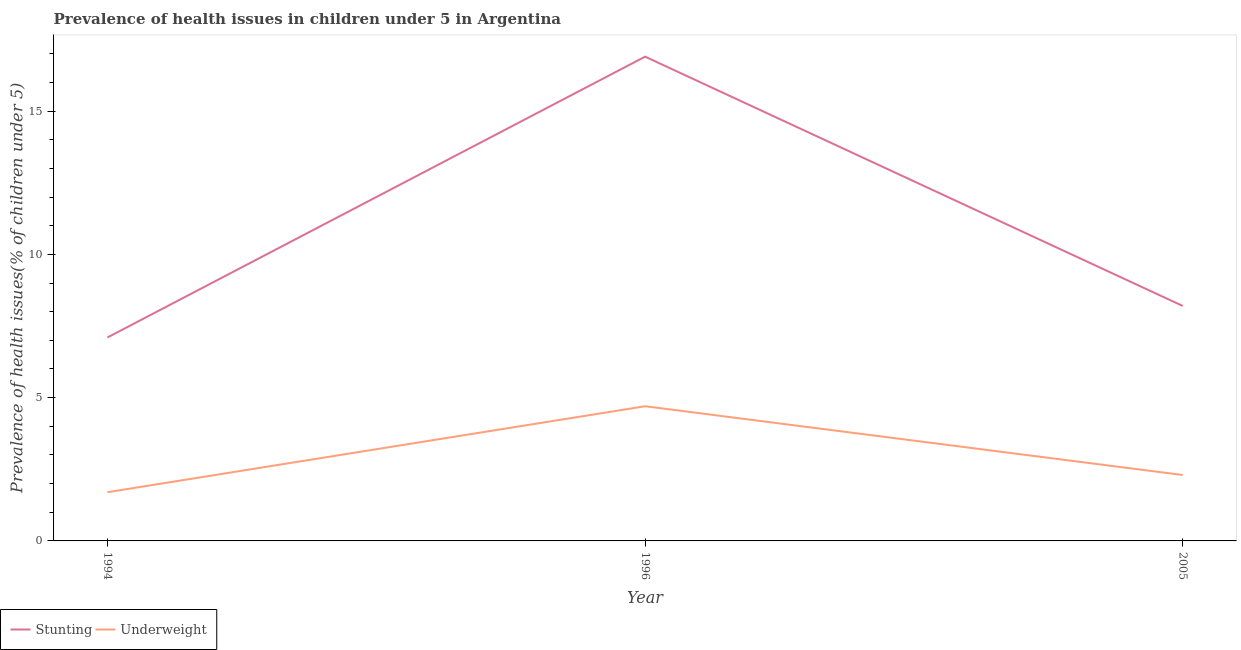What is the percentage of underweight children in 2005?
Provide a short and direct response. 2.3. Across all years, what is the maximum percentage of underweight children?
Your response must be concise. 4.7. Across all years, what is the minimum percentage of underweight children?
Ensure brevity in your answer.  1.7. In which year was the percentage of stunted children maximum?
Make the answer very short. 1996. In which year was the percentage of underweight children minimum?
Offer a terse response. 1994. What is the total percentage of stunted children in the graph?
Your answer should be compact. 32.2. What is the difference between the percentage of stunted children in 1994 and that in 1996?
Provide a short and direct response. -9.8. What is the difference between the percentage of stunted children in 1994 and the percentage of underweight children in 2005?
Provide a succinct answer. 4.8. What is the average percentage of stunted children per year?
Provide a short and direct response. 10.73. In the year 1994, what is the difference between the percentage of stunted children and percentage of underweight children?
Provide a short and direct response. 5.4. In how many years, is the percentage of underweight children greater than 1 %?
Ensure brevity in your answer.  3. What is the ratio of the percentage of stunted children in 1994 to that in 2005?
Give a very brief answer. 0.87. Is the percentage of stunted children in 1994 less than that in 2005?
Give a very brief answer. Yes. What is the difference between the highest and the second highest percentage of underweight children?
Offer a terse response. 2.4. What is the difference between the highest and the lowest percentage of underweight children?
Give a very brief answer. 3. Is the sum of the percentage of underweight children in 1996 and 2005 greater than the maximum percentage of stunted children across all years?
Your answer should be compact. No. Is the percentage of stunted children strictly less than the percentage of underweight children over the years?
Your answer should be very brief. No. How many years are there in the graph?
Your response must be concise. 3. Does the graph contain any zero values?
Your answer should be compact. No. Does the graph contain grids?
Provide a short and direct response. No. What is the title of the graph?
Offer a very short reply. Prevalence of health issues in children under 5 in Argentina. Does "ODA received" appear as one of the legend labels in the graph?
Give a very brief answer. No. What is the label or title of the X-axis?
Provide a short and direct response. Year. What is the label or title of the Y-axis?
Keep it short and to the point. Prevalence of health issues(% of children under 5). What is the Prevalence of health issues(% of children under 5) of Stunting in 1994?
Make the answer very short. 7.1. What is the Prevalence of health issues(% of children under 5) in Underweight in 1994?
Offer a very short reply. 1.7. What is the Prevalence of health issues(% of children under 5) of Stunting in 1996?
Your response must be concise. 16.9. What is the Prevalence of health issues(% of children under 5) in Underweight in 1996?
Give a very brief answer. 4.7. What is the Prevalence of health issues(% of children under 5) of Stunting in 2005?
Offer a terse response. 8.2. What is the Prevalence of health issues(% of children under 5) of Underweight in 2005?
Provide a succinct answer. 2.3. Across all years, what is the maximum Prevalence of health issues(% of children under 5) of Stunting?
Provide a short and direct response. 16.9. Across all years, what is the maximum Prevalence of health issues(% of children under 5) of Underweight?
Give a very brief answer. 4.7. Across all years, what is the minimum Prevalence of health issues(% of children under 5) in Stunting?
Your answer should be compact. 7.1. Across all years, what is the minimum Prevalence of health issues(% of children under 5) in Underweight?
Give a very brief answer. 1.7. What is the total Prevalence of health issues(% of children under 5) of Stunting in the graph?
Your answer should be very brief. 32.2. What is the total Prevalence of health issues(% of children under 5) in Underweight in the graph?
Offer a terse response. 8.7. What is the difference between the Prevalence of health issues(% of children under 5) in Stunting in 1994 and that in 1996?
Your response must be concise. -9.8. What is the difference between the Prevalence of health issues(% of children under 5) in Underweight in 1994 and that in 1996?
Make the answer very short. -3. What is the difference between the Prevalence of health issues(% of children under 5) of Stunting in 1994 and that in 2005?
Provide a short and direct response. -1.1. What is the difference between the Prevalence of health issues(% of children under 5) of Underweight in 1994 and that in 2005?
Offer a terse response. -0.6. What is the difference between the Prevalence of health issues(% of children under 5) of Stunting in 1996 and that in 2005?
Offer a very short reply. 8.7. What is the difference between the Prevalence of health issues(% of children under 5) of Underweight in 1996 and that in 2005?
Keep it short and to the point. 2.4. What is the difference between the Prevalence of health issues(% of children under 5) in Stunting in 1994 and the Prevalence of health issues(% of children under 5) in Underweight in 1996?
Ensure brevity in your answer.  2.4. What is the average Prevalence of health issues(% of children under 5) in Stunting per year?
Provide a succinct answer. 10.73. In the year 1996, what is the difference between the Prevalence of health issues(% of children under 5) of Stunting and Prevalence of health issues(% of children under 5) of Underweight?
Your answer should be very brief. 12.2. In the year 2005, what is the difference between the Prevalence of health issues(% of children under 5) of Stunting and Prevalence of health issues(% of children under 5) of Underweight?
Your response must be concise. 5.9. What is the ratio of the Prevalence of health issues(% of children under 5) of Stunting in 1994 to that in 1996?
Keep it short and to the point. 0.42. What is the ratio of the Prevalence of health issues(% of children under 5) in Underweight in 1994 to that in 1996?
Make the answer very short. 0.36. What is the ratio of the Prevalence of health issues(% of children under 5) in Stunting in 1994 to that in 2005?
Your response must be concise. 0.87. What is the ratio of the Prevalence of health issues(% of children under 5) in Underweight in 1994 to that in 2005?
Provide a succinct answer. 0.74. What is the ratio of the Prevalence of health issues(% of children under 5) of Stunting in 1996 to that in 2005?
Ensure brevity in your answer.  2.06. What is the ratio of the Prevalence of health issues(% of children under 5) of Underweight in 1996 to that in 2005?
Offer a terse response. 2.04. What is the difference between the highest and the second highest Prevalence of health issues(% of children under 5) of Underweight?
Give a very brief answer. 2.4. 